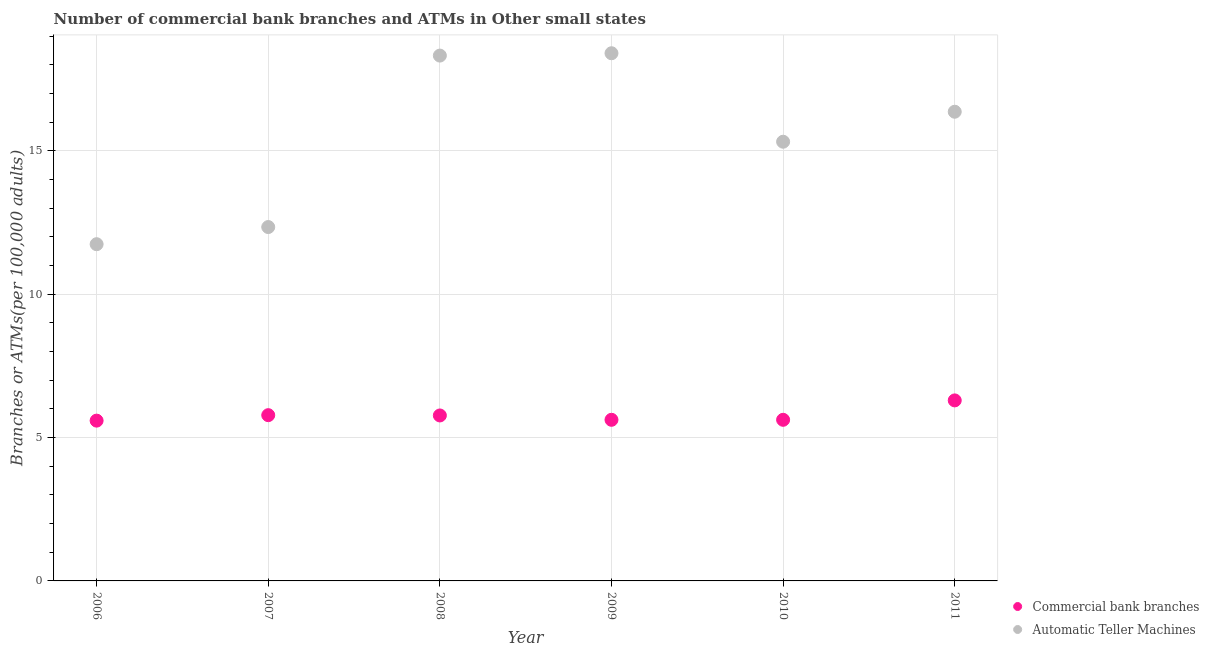Is the number of dotlines equal to the number of legend labels?
Make the answer very short. Yes. What is the number of atms in 2011?
Provide a succinct answer. 16.36. Across all years, what is the maximum number of atms?
Keep it short and to the point. 18.4. Across all years, what is the minimum number of atms?
Offer a very short reply. 11.74. In which year was the number of atms maximum?
Offer a very short reply. 2009. What is the total number of atms in the graph?
Provide a succinct answer. 92.48. What is the difference between the number of atms in 2009 and that in 2011?
Keep it short and to the point. 2.04. What is the difference between the number of commercal bank branches in 2007 and the number of atms in 2006?
Make the answer very short. -5.96. What is the average number of atms per year?
Provide a succinct answer. 15.41. In the year 2009, what is the difference between the number of atms and number of commercal bank branches?
Your answer should be very brief. 12.78. In how many years, is the number of atms greater than 4?
Ensure brevity in your answer.  6. What is the ratio of the number of atms in 2008 to that in 2009?
Provide a succinct answer. 1. Is the difference between the number of commercal bank branches in 2006 and 2011 greater than the difference between the number of atms in 2006 and 2011?
Offer a terse response. Yes. What is the difference between the highest and the second highest number of atms?
Your answer should be compact. 0.08. What is the difference between the highest and the lowest number of commercal bank branches?
Your answer should be very brief. 0.71. Does the number of atms monotonically increase over the years?
Offer a terse response. No. How many years are there in the graph?
Provide a short and direct response. 6. What is the difference between two consecutive major ticks on the Y-axis?
Your answer should be very brief. 5. Are the values on the major ticks of Y-axis written in scientific E-notation?
Offer a terse response. No. Does the graph contain any zero values?
Ensure brevity in your answer.  No. Does the graph contain grids?
Your answer should be very brief. Yes. Where does the legend appear in the graph?
Make the answer very short. Bottom right. How are the legend labels stacked?
Keep it short and to the point. Vertical. What is the title of the graph?
Keep it short and to the point. Number of commercial bank branches and ATMs in Other small states. Does "Researchers" appear as one of the legend labels in the graph?
Offer a terse response. No. What is the label or title of the Y-axis?
Your answer should be very brief. Branches or ATMs(per 100,0 adults). What is the Branches or ATMs(per 100,000 adults) in Commercial bank branches in 2006?
Your response must be concise. 5.59. What is the Branches or ATMs(per 100,000 adults) of Automatic Teller Machines in 2006?
Keep it short and to the point. 11.74. What is the Branches or ATMs(per 100,000 adults) of Commercial bank branches in 2007?
Give a very brief answer. 5.78. What is the Branches or ATMs(per 100,000 adults) in Automatic Teller Machines in 2007?
Make the answer very short. 12.34. What is the Branches or ATMs(per 100,000 adults) in Commercial bank branches in 2008?
Offer a terse response. 5.77. What is the Branches or ATMs(per 100,000 adults) in Automatic Teller Machines in 2008?
Your answer should be compact. 18.32. What is the Branches or ATMs(per 100,000 adults) in Commercial bank branches in 2009?
Offer a very short reply. 5.62. What is the Branches or ATMs(per 100,000 adults) in Automatic Teller Machines in 2009?
Provide a short and direct response. 18.4. What is the Branches or ATMs(per 100,000 adults) of Commercial bank branches in 2010?
Your answer should be very brief. 5.62. What is the Branches or ATMs(per 100,000 adults) of Automatic Teller Machines in 2010?
Keep it short and to the point. 15.32. What is the Branches or ATMs(per 100,000 adults) in Commercial bank branches in 2011?
Provide a succinct answer. 6.3. What is the Branches or ATMs(per 100,000 adults) of Automatic Teller Machines in 2011?
Provide a short and direct response. 16.36. Across all years, what is the maximum Branches or ATMs(per 100,000 adults) of Commercial bank branches?
Provide a short and direct response. 6.3. Across all years, what is the maximum Branches or ATMs(per 100,000 adults) in Automatic Teller Machines?
Your answer should be compact. 18.4. Across all years, what is the minimum Branches or ATMs(per 100,000 adults) of Commercial bank branches?
Your answer should be very brief. 5.59. Across all years, what is the minimum Branches or ATMs(per 100,000 adults) in Automatic Teller Machines?
Make the answer very short. 11.74. What is the total Branches or ATMs(per 100,000 adults) of Commercial bank branches in the graph?
Offer a very short reply. 34.67. What is the total Branches or ATMs(per 100,000 adults) in Automatic Teller Machines in the graph?
Ensure brevity in your answer.  92.48. What is the difference between the Branches or ATMs(per 100,000 adults) in Commercial bank branches in 2006 and that in 2007?
Provide a succinct answer. -0.19. What is the difference between the Branches or ATMs(per 100,000 adults) of Automatic Teller Machines in 2006 and that in 2007?
Keep it short and to the point. -0.6. What is the difference between the Branches or ATMs(per 100,000 adults) of Commercial bank branches in 2006 and that in 2008?
Keep it short and to the point. -0.18. What is the difference between the Branches or ATMs(per 100,000 adults) in Automatic Teller Machines in 2006 and that in 2008?
Your answer should be very brief. -6.58. What is the difference between the Branches or ATMs(per 100,000 adults) in Commercial bank branches in 2006 and that in 2009?
Your response must be concise. -0.03. What is the difference between the Branches or ATMs(per 100,000 adults) in Automatic Teller Machines in 2006 and that in 2009?
Give a very brief answer. -6.66. What is the difference between the Branches or ATMs(per 100,000 adults) of Commercial bank branches in 2006 and that in 2010?
Your response must be concise. -0.03. What is the difference between the Branches or ATMs(per 100,000 adults) in Automatic Teller Machines in 2006 and that in 2010?
Your answer should be very brief. -3.57. What is the difference between the Branches or ATMs(per 100,000 adults) in Commercial bank branches in 2006 and that in 2011?
Provide a succinct answer. -0.71. What is the difference between the Branches or ATMs(per 100,000 adults) in Automatic Teller Machines in 2006 and that in 2011?
Provide a short and direct response. -4.62. What is the difference between the Branches or ATMs(per 100,000 adults) of Commercial bank branches in 2007 and that in 2008?
Ensure brevity in your answer.  0.01. What is the difference between the Branches or ATMs(per 100,000 adults) of Automatic Teller Machines in 2007 and that in 2008?
Offer a very short reply. -5.98. What is the difference between the Branches or ATMs(per 100,000 adults) in Commercial bank branches in 2007 and that in 2009?
Keep it short and to the point. 0.16. What is the difference between the Branches or ATMs(per 100,000 adults) in Automatic Teller Machines in 2007 and that in 2009?
Your answer should be very brief. -6.06. What is the difference between the Branches or ATMs(per 100,000 adults) in Commercial bank branches in 2007 and that in 2010?
Ensure brevity in your answer.  0.16. What is the difference between the Branches or ATMs(per 100,000 adults) in Automatic Teller Machines in 2007 and that in 2010?
Give a very brief answer. -2.98. What is the difference between the Branches or ATMs(per 100,000 adults) of Commercial bank branches in 2007 and that in 2011?
Offer a very short reply. -0.52. What is the difference between the Branches or ATMs(per 100,000 adults) in Automatic Teller Machines in 2007 and that in 2011?
Provide a succinct answer. -4.02. What is the difference between the Branches or ATMs(per 100,000 adults) of Commercial bank branches in 2008 and that in 2009?
Offer a terse response. 0.15. What is the difference between the Branches or ATMs(per 100,000 adults) in Automatic Teller Machines in 2008 and that in 2009?
Give a very brief answer. -0.08. What is the difference between the Branches or ATMs(per 100,000 adults) of Commercial bank branches in 2008 and that in 2010?
Ensure brevity in your answer.  0.15. What is the difference between the Branches or ATMs(per 100,000 adults) in Automatic Teller Machines in 2008 and that in 2010?
Provide a succinct answer. 3. What is the difference between the Branches or ATMs(per 100,000 adults) in Commercial bank branches in 2008 and that in 2011?
Give a very brief answer. -0.53. What is the difference between the Branches or ATMs(per 100,000 adults) in Automatic Teller Machines in 2008 and that in 2011?
Your response must be concise. 1.96. What is the difference between the Branches or ATMs(per 100,000 adults) of Commercial bank branches in 2009 and that in 2010?
Offer a very short reply. 0. What is the difference between the Branches or ATMs(per 100,000 adults) in Automatic Teller Machines in 2009 and that in 2010?
Ensure brevity in your answer.  3.09. What is the difference between the Branches or ATMs(per 100,000 adults) in Commercial bank branches in 2009 and that in 2011?
Provide a short and direct response. -0.68. What is the difference between the Branches or ATMs(per 100,000 adults) of Automatic Teller Machines in 2009 and that in 2011?
Make the answer very short. 2.04. What is the difference between the Branches or ATMs(per 100,000 adults) of Commercial bank branches in 2010 and that in 2011?
Give a very brief answer. -0.68. What is the difference between the Branches or ATMs(per 100,000 adults) in Automatic Teller Machines in 2010 and that in 2011?
Offer a very short reply. -1.05. What is the difference between the Branches or ATMs(per 100,000 adults) in Commercial bank branches in 2006 and the Branches or ATMs(per 100,000 adults) in Automatic Teller Machines in 2007?
Offer a terse response. -6.75. What is the difference between the Branches or ATMs(per 100,000 adults) in Commercial bank branches in 2006 and the Branches or ATMs(per 100,000 adults) in Automatic Teller Machines in 2008?
Keep it short and to the point. -12.73. What is the difference between the Branches or ATMs(per 100,000 adults) in Commercial bank branches in 2006 and the Branches or ATMs(per 100,000 adults) in Automatic Teller Machines in 2009?
Ensure brevity in your answer.  -12.81. What is the difference between the Branches or ATMs(per 100,000 adults) of Commercial bank branches in 2006 and the Branches or ATMs(per 100,000 adults) of Automatic Teller Machines in 2010?
Offer a very short reply. -9.73. What is the difference between the Branches or ATMs(per 100,000 adults) of Commercial bank branches in 2006 and the Branches or ATMs(per 100,000 adults) of Automatic Teller Machines in 2011?
Your answer should be compact. -10.77. What is the difference between the Branches or ATMs(per 100,000 adults) in Commercial bank branches in 2007 and the Branches or ATMs(per 100,000 adults) in Automatic Teller Machines in 2008?
Your answer should be very brief. -12.54. What is the difference between the Branches or ATMs(per 100,000 adults) in Commercial bank branches in 2007 and the Branches or ATMs(per 100,000 adults) in Automatic Teller Machines in 2009?
Your response must be concise. -12.62. What is the difference between the Branches or ATMs(per 100,000 adults) of Commercial bank branches in 2007 and the Branches or ATMs(per 100,000 adults) of Automatic Teller Machines in 2010?
Provide a short and direct response. -9.54. What is the difference between the Branches or ATMs(per 100,000 adults) in Commercial bank branches in 2007 and the Branches or ATMs(per 100,000 adults) in Automatic Teller Machines in 2011?
Your answer should be very brief. -10.58. What is the difference between the Branches or ATMs(per 100,000 adults) in Commercial bank branches in 2008 and the Branches or ATMs(per 100,000 adults) in Automatic Teller Machines in 2009?
Provide a succinct answer. -12.63. What is the difference between the Branches or ATMs(per 100,000 adults) of Commercial bank branches in 2008 and the Branches or ATMs(per 100,000 adults) of Automatic Teller Machines in 2010?
Keep it short and to the point. -9.55. What is the difference between the Branches or ATMs(per 100,000 adults) in Commercial bank branches in 2008 and the Branches or ATMs(per 100,000 adults) in Automatic Teller Machines in 2011?
Offer a very short reply. -10.59. What is the difference between the Branches or ATMs(per 100,000 adults) in Commercial bank branches in 2009 and the Branches or ATMs(per 100,000 adults) in Automatic Teller Machines in 2010?
Your answer should be very brief. -9.7. What is the difference between the Branches or ATMs(per 100,000 adults) of Commercial bank branches in 2009 and the Branches or ATMs(per 100,000 adults) of Automatic Teller Machines in 2011?
Give a very brief answer. -10.74. What is the difference between the Branches or ATMs(per 100,000 adults) of Commercial bank branches in 2010 and the Branches or ATMs(per 100,000 adults) of Automatic Teller Machines in 2011?
Your answer should be very brief. -10.74. What is the average Branches or ATMs(per 100,000 adults) of Commercial bank branches per year?
Your answer should be very brief. 5.78. What is the average Branches or ATMs(per 100,000 adults) in Automatic Teller Machines per year?
Provide a short and direct response. 15.41. In the year 2006, what is the difference between the Branches or ATMs(per 100,000 adults) of Commercial bank branches and Branches or ATMs(per 100,000 adults) of Automatic Teller Machines?
Your response must be concise. -6.15. In the year 2007, what is the difference between the Branches or ATMs(per 100,000 adults) in Commercial bank branches and Branches or ATMs(per 100,000 adults) in Automatic Teller Machines?
Ensure brevity in your answer.  -6.56. In the year 2008, what is the difference between the Branches or ATMs(per 100,000 adults) in Commercial bank branches and Branches or ATMs(per 100,000 adults) in Automatic Teller Machines?
Make the answer very short. -12.55. In the year 2009, what is the difference between the Branches or ATMs(per 100,000 adults) of Commercial bank branches and Branches or ATMs(per 100,000 adults) of Automatic Teller Machines?
Ensure brevity in your answer.  -12.78. In the year 2010, what is the difference between the Branches or ATMs(per 100,000 adults) of Commercial bank branches and Branches or ATMs(per 100,000 adults) of Automatic Teller Machines?
Ensure brevity in your answer.  -9.7. In the year 2011, what is the difference between the Branches or ATMs(per 100,000 adults) in Commercial bank branches and Branches or ATMs(per 100,000 adults) in Automatic Teller Machines?
Your answer should be compact. -10.07. What is the ratio of the Branches or ATMs(per 100,000 adults) in Commercial bank branches in 2006 to that in 2007?
Your answer should be very brief. 0.97. What is the ratio of the Branches or ATMs(per 100,000 adults) in Automatic Teller Machines in 2006 to that in 2007?
Keep it short and to the point. 0.95. What is the ratio of the Branches or ATMs(per 100,000 adults) in Commercial bank branches in 2006 to that in 2008?
Provide a short and direct response. 0.97. What is the ratio of the Branches or ATMs(per 100,000 adults) of Automatic Teller Machines in 2006 to that in 2008?
Your answer should be very brief. 0.64. What is the ratio of the Branches or ATMs(per 100,000 adults) of Commercial bank branches in 2006 to that in 2009?
Your response must be concise. 0.99. What is the ratio of the Branches or ATMs(per 100,000 adults) in Automatic Teller Machines in 2006 to that in 2009?
Make the answer very short. 0.64. What is the ratio of the Branches or ATMs(per 100,000 adults) of Automatic Teller Machines in 2006 to that in 2010?
Give a very brief answer. 0.77. What is the ratio of the Branches or ATMs(per 100,000 adults) of Commercial bank branches in 2006 to that in 2011?
Provide a succinct answer. 0.89. What is the ratio of the Branches or ATMs(per 100,000 adults) in Automatic Teller Machines in 2006 to that in 2011?
Your answer should be compact. 0.72. What is the ratio of the Branches or ATMs(per 100,000 adults) in Automatic Teller Machines in 2007 to that in 2008?
Ensure brevity in your answer.  0.67. What is the ratio of the Branches or ATMs(per 100,000 adults) in Commercial bank branches in 2007 to that in 2009?
Ensure brevity in your answer.  1.03. What is the ratio of the Branches or ATMs(per 100,000 adults) of Automatic Teller Machines in 2007 to that in 2009?
Give a very brief answer. 0.67. What is the ratio of the Branches or ATMs(per 100,000 adults) of Commercial bank branches in 2007 to that in 2010?
Ensure brevity in your answer.  1.03. What is the ratio of the Branches or ATMs(per 100,000 adults) of Automatic Teller Machines in 2007 to that in 2010?
Keep it short and to the point. 0.81. What is the ratio of the Branches or ATMs(per 100,000 adults) of Commercial bank branches in 2007 to that in 2011?
Make the answer very short. 0.92. What is the ratio of the Branches or ATMs(per 100,000 adults) in Automatic Teller Machines in 2007 to that in 2011?
Keep it short and to the point. 0.75. What is the ratio of the Branches or ATMs(per 100,000 adults) of Commercial bank branches in 2008 to that in 2009?
Give a very brief answer. 1.03. What is the ratio of the Branches or ATMs(per 100,000 adults) in Automatic Teller Machines in 2008 to that in 2009?
Keep it short and to the point. 1. What is the ratio of the Branches or ATMs(per 100,000 adults) of Commercial bank branches in 2008 to that in 2010?
Offer a terse response. 1.03. What is the ratio of the Branches or ATMs(per 100,000 adults) of Automatic Teller Machines in 2008 to that in 2010?
Offer a terse response. 1.2. What is the ratio of the Branches or ATMs(per 100,000 adults) in Commercial bank branches in 2008 to that in 2011?
Keep it short and to the point. 0.92. What is the ratio of the Branches or ATMs(per 100,000 adults) in Automatic Teller Machines in 2008 to that in 2011?
Ensure brevity in your answer.  1.12. What is the ratio of the Branches or ATMs(per 100,000 adults) of Automatic Teller Machines in 2009 to that in 2010?
Provide a succinct answer. 1.2. What is the ratio of the Branches or ATMs(per 100,000 adults) in Commercial bank branches in 2009 to that in 2011?
Make the answer very short. 0.89. What is the ratio of the Branches or ATMs(per 100,000 adults) in Automatic Teller Machines in 2009 to that in 2011?
Ensure brevity in your answer.  1.12. What is the ratio of the Branches or ATMs(per 100,000 adults) in Commercial bank branches in 2010 to that in 2011?
Offer a very short reply. 0.89. What is the ratio of the Branches or ATMs(per 100,000 adults) of Automatic Teller Machines in 2010 to that in 2011?
Keep it short and to the point. 0.94. What is the difference between the highest and the second highest Branches or ATMs(per 100,000 adults) in Commercial bank branches?
Offer a terse response. 0.52. What is the difference between the highest and the second highest Branches or ATMs(per 100,000 adults) of Automatic Teller Machines?
Keep it short and to the point. 0.08. What is the difference between the highest and the lowest Branches or ATMs(per 100,000 adults) of Commercial bank branches?
Ensure brevity in your answer.  0.71. What is the difference between the highest and the lowest Branches or ATMs(per 100,000 adults) in Automatic Teller Machines?
Ensure brevity in your answer.  6.66. 